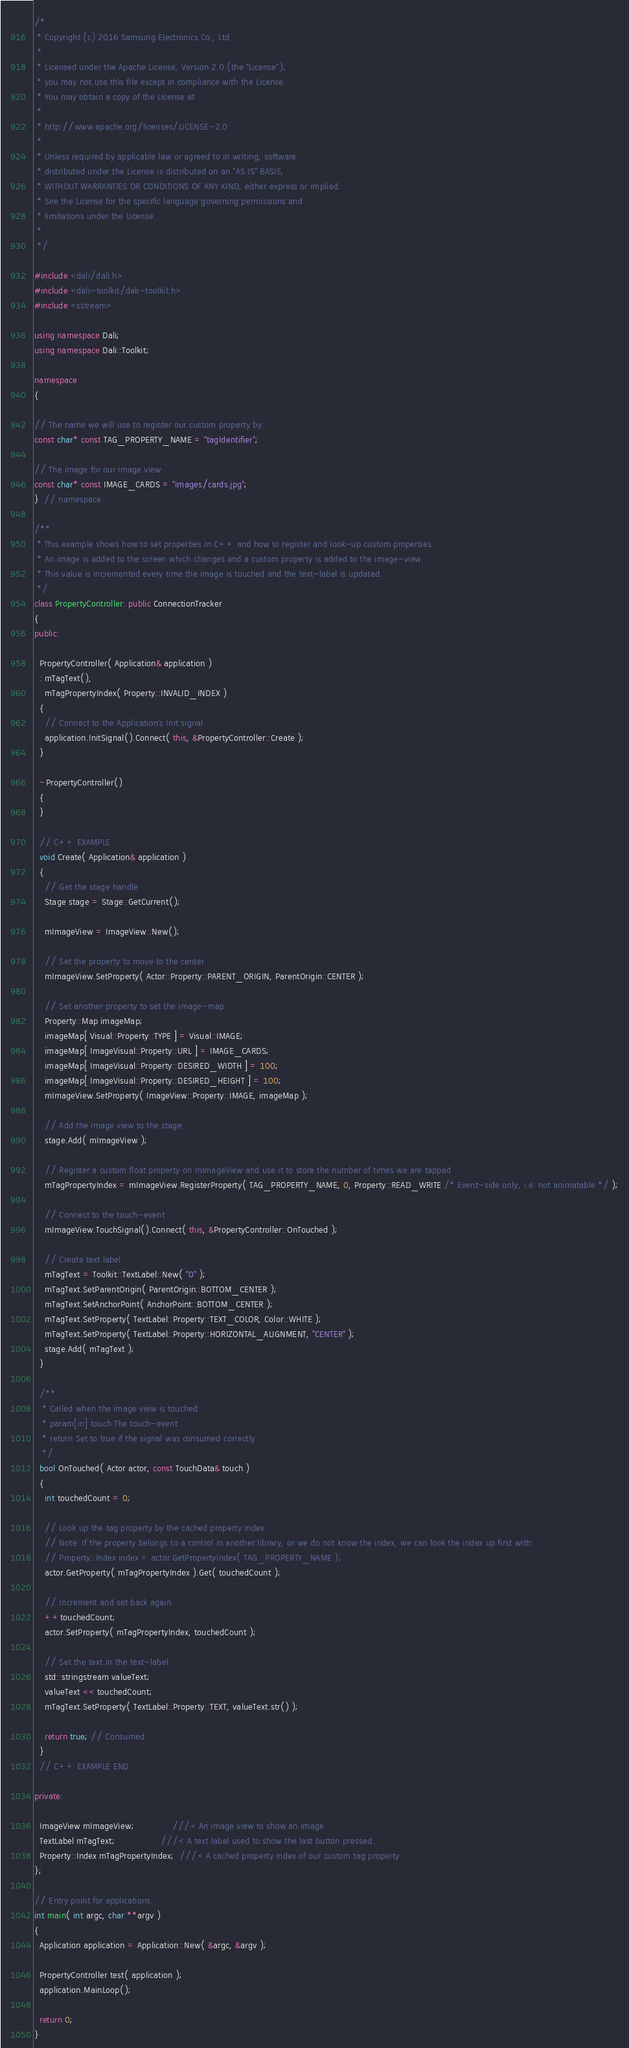<code> <loc_0><loc_0><loc_500><loc_500><_C++_>/*
 * Copyright (c) 2016 Samsung Electronics Co., Ltd.
 *
 * Licensed under the Apache License, Version 2.0 (the "License");
 * you may not use this file except in compliance with the License.
 * You may obtain a copy of the License at
 *
 * http://www.apache.org/licenses/LICENSE-2.0
 *
 * Unless required by applicable law or agreed to in writing, software
 * distributed under the License is distributed on an "AS IS" BASIS,
 * WITHOUT WARRANTIES OR CONDITIONS OF ANY KIND, either express or implied.
 * See the License for the specific language governing permissions and
 * limitations under the License.
 *
 */

#include <dali/dali.h>
#include <dali-toolkit/dali-toolkit.h>
#include <sstream>

using namespace Dali;
using namespace Dali::Toolkit;

namespace
{

// The name we will use to register our custom property by.
const char* const TAG_PROPERTY_NAME = "tagIdentifier";

// The image for our image view
const char* const IMAGE_CARDS = "images/cards.jpg";
}  // namespace

/**
 * This example shows how to set properties in C++ and how to register and look-up custom properties.
 * An image is added to the screen which changes and a custom property is added to the image-view.
 * This value is incremented every time the image is touched and the text-label is updated.
 */
class PropertyController: public ConnectionTracker
{
public:

  PropertyController( Application& application )
  : mTagText(),
    mTagPropertyIndex( Property::INVALID_INDEX )
  {
    // Connect to the Application's Init signal
    application.InitSignal().Connect( this, &PropertyController::Create );
  }

  ~PropertyController()
  {
  }

  // C++ EXAMPLE
  void Create( Application& application )
  {
    // Get the stage handle
    Stage stage = Stage::GetCurrent();

    mImageView = ImageView::New();

    // Set the property to move to the center
    mImageView.SetProperty( Actor::Property::PARENT_ORIGIN, ParentOrigin::CENTER );

    // Set another property to set the image-map
    Property::Map imageMap;
    imageMap[ Visual::Property::TYPE ] = Visual::IMAGE;
    imageMap[ ImageVisual::Property::URL ] = IMAGE_CARDS;
    imageMap[ ImageVisual::Property::DESIRED_WIDTH ] = 100;
    imageMap[ ImageVisual::Property::DESIRED_HEIGHT ] = 100;
    mImageView.SetProperty( ImageView::Property::IMAGE, imageMap );

    // Add the image view to the stage
    stage.Add( mImageView );

    // Register a custom float property on mImageView and use it to store the number of times we are tapped
    mTagPropertyIndex = mImageView.RegisterProperty( TAG_PROPERTY_NAME, 0, Property::READ_WRITE /* Event-side only, i.e. not animatable */ );

    // Connect to the touch-event
    mImageView.TouchSignal().Connect( this, &PropertyController::OnTouched );

    // Create text label
    mTagText = Toolkit::TextLabel::New( "0" );
    mTagText.SetParentOrigin( ParentOrigin::BOTTOM_CENTER );
    mTagText.SetAnchorPoint( AnchorPoint::BOTTOM_CENTER );
    mTagText.SetProperty( TextLabel::Property::TEXT_COLOR, Color::WHITE );
    mTagText.SetProperty( TextLabel::Property::HORIZONTAL_ALIGNMENT, "CENTER" );
    stage.Add( mTagText );
  }

  /**
   * Called when the image view is touched
   * param[in] touch The touch-event
   * return Set to true if the signal was consumed correctly
   */
  bool OnTouched( Actor actor, const TouchData& touch )
  {
    int touchedCount = 0;

    // Look up the tag property by the cached property index.
    // Note: If the property belongs to a control in another library, or we do not know the index, we can look the index up first with:
    // Property::Index index = actor.GetPropertyIndex( TAG_PROPERTY_NAME );
    actor.GetProperty( mTagPropertyIndex ).Get( touchedCount );

    // Increment and set back again
    ++touchedCount;
    actor.SetProperty( mTagPropertyIndex, touchedCount );

    // Set the text in the text-label
    std::stringstream valueText;
    valueText << touchedCount;
    mTagText.SetProperty( TextLabel::Property::TEXT, valueText.str() );

    return true; // Consumed
  }
  // C++ EXAMPLE END

private:

  ImageView mImageView;              ///< An image view to show an image
  TextLabel mTagText;                 ///< A text label used to show the last button pressed.
  Property::Index mTagPropertyIndex;  ///< A cached property index of our custom tag property.
};

// Entry point for applications.
int main( int argc, char **argv )
{
  Application application = Application::New( &argc, &argv );

  PropertyController test( application );
  application.MainLoop();

  return 0;
}
</code> 